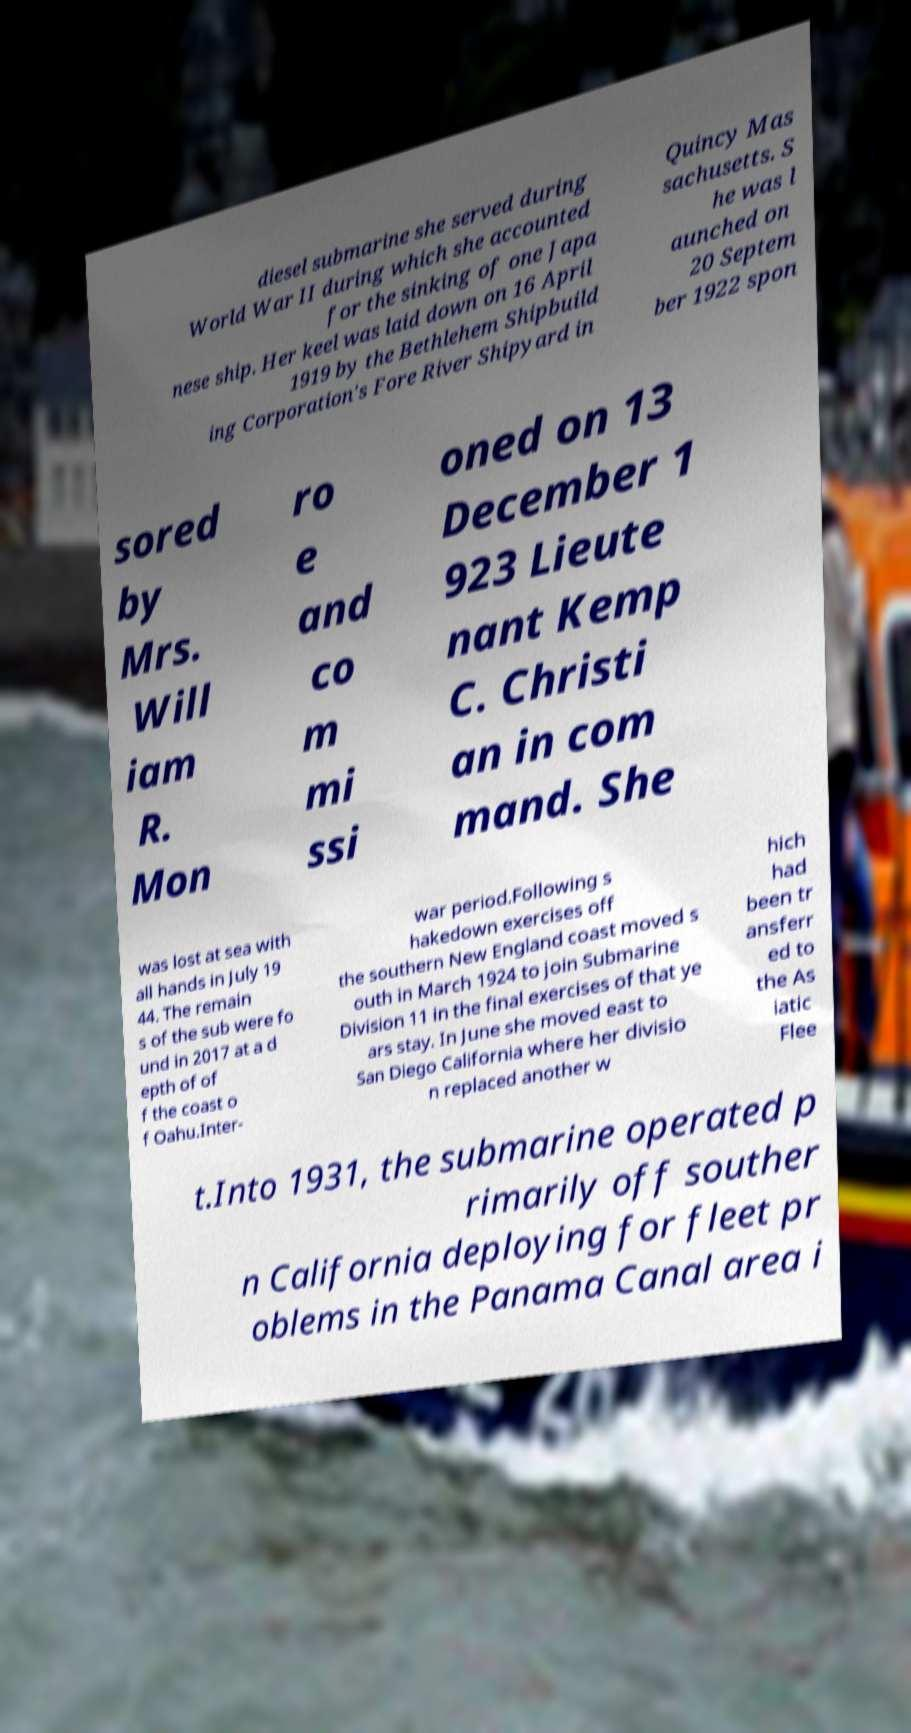I need the written content from this picture converted into text. Can you do that? diesel submarine she served during World War II during which she accounted for the sinking of one Japa nese ship. Her keel was laid down on 16 April 1919 by the Bethlehem Shipbuild ing Corporation's Fore River Shipyard in Quincy Mas sachusetts. S he was l aunched on 20 Septem ber 1922 spon sored by Mrs. Will iam R. Mon ro e and co m mi ssi oned on 13 December 1 923 Lieute nant Kemp C. Christi an in com mand. She was lost at sea with all hands in July 19 44. The remain s of the sub were fo und in 2017 at a d epth of of f the coast o f Oahu.Inter- war period.Following s hakedown exercises off the southern New England coast moved s outh in March 1924 to join Submarine Division 11 in the final exercises of that ye ars stay. In June she moved east to San Diego California where her divisio n replaced another w hich had been tr ansferr ed to the As iatic Flee t.Into 1931, the submarine operated p rimarily off souther n California deploying for fleet pr oblems in the Panama Canal area i 